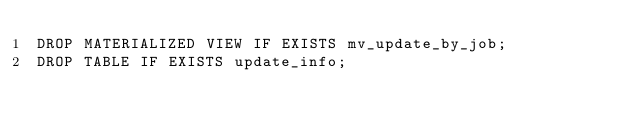Convert code to text. <code><loc_0><loc_0><loc_500><loc_500><_SQL_>DROP MATERIALIZED VIEW IF EXISTS mv_update_by_job;
DROP TABLE IF EXISTS update_info;
</code> 